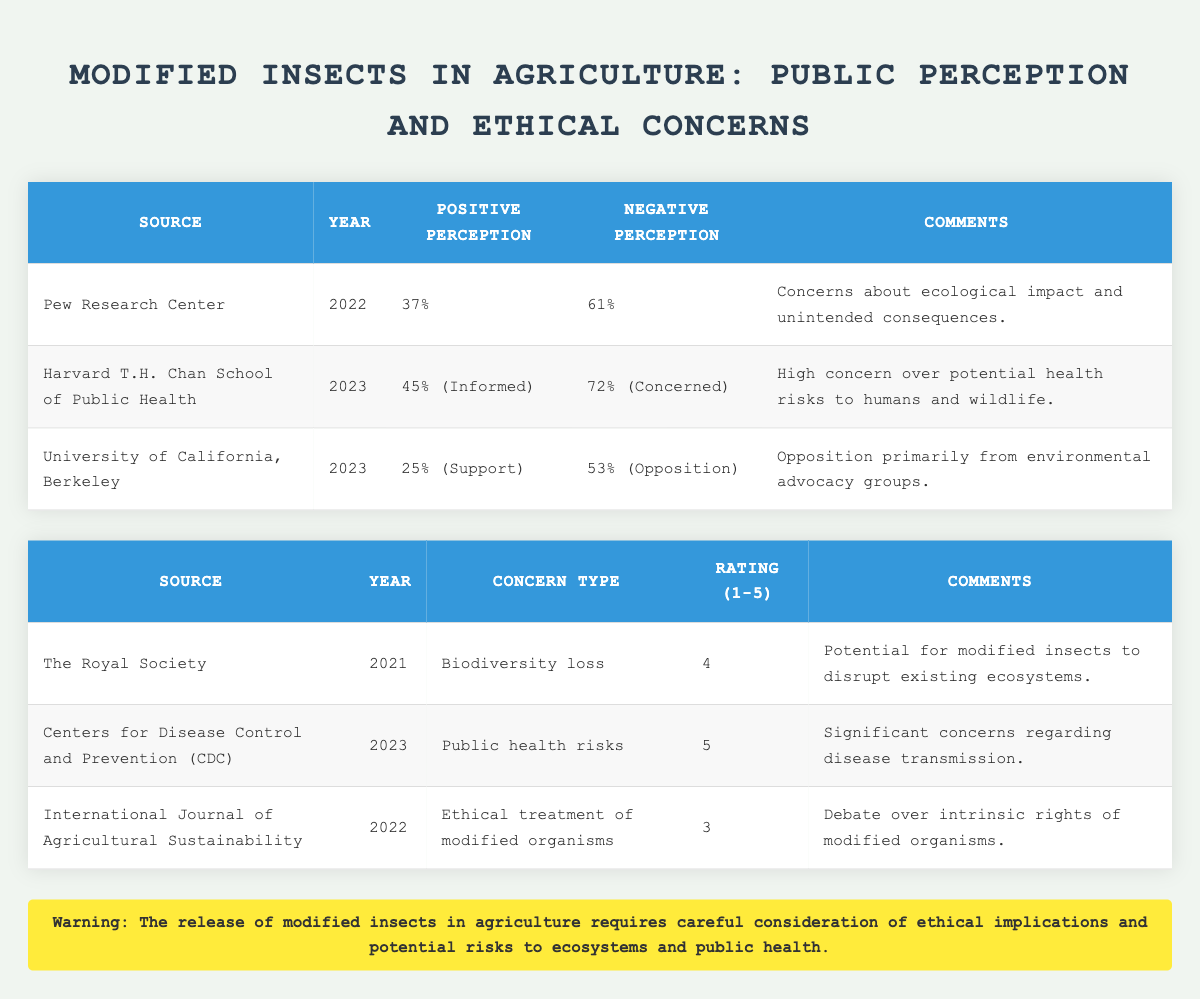What percentage of respondents from the Pew Research Center had a negative perception of modified insects? According to the table, the Pew Research Center reported a negative perception of 61% regarding modified insects.
Answer: 61% What is the highest rated ethical concern regarding modified insects according to the CDC? The CDC assigned a rating of 5 to the concern about public health risks, indicating it as the highest rated concern among those listed in the table.
Answer: Public health risks (rating 5) How does the support rate for modified insects from the University of California, Berkeley compare to the opposition rate? The support rate is 25%, while the opposition rate is 53%. The opposition is significantly higher than the support, with a difference of 28%.
Answer: Opposition is higher by 28% Is the concern about public health risks rated lower than the concern about biodiversity loss? No, the public health risks rated a 5, while biodiversity loss rated a 4, meaning public health risks are rated higher.
Answer: No What is the average rating of ethical concerns listed in the table? To find the average, sum the ratings: (4 + 5 + 3) = 12. There are three concerns, so the average rating is 12/3 = 4.
Answer: 4 What percentage of the population is concerned about the release of modified insects according to the Harvard T.H. Chan School of Public Health? The Harvard T.H. Chan School of Public Health reported that 72% of respondents expressed concern about the release of modified insects.
Answer: 72% Is there a higher percentage of informed support for modified insects or opposition against them from the data collected in 2023? The informed support is 45%, and the opposition mentioned is 53%. Thus, opposition is higher by 8%.
Answer: Opposition is higher by 8% Which source rated ethical treatment of modified organisms with a score of 3, and how does it compare to the biodiversity loss rating? The International Journal of Agricultural Sustainability rated the ethical treatment of modified organisms with a 3, which is lower than the rating of 4 given for biodiversity loss.
Answer: International Journal of Agricultural Sustainability; lower than biodiversity loss rating What comments were provided by the Pew Research Center regarding public perception? The comments from the Pew Research Center noted "Concerns about ecological impact and unintended consequences," indicating the reasons behind the negative perception.
Answer: Concerns about ecological impact and unintended consequences 